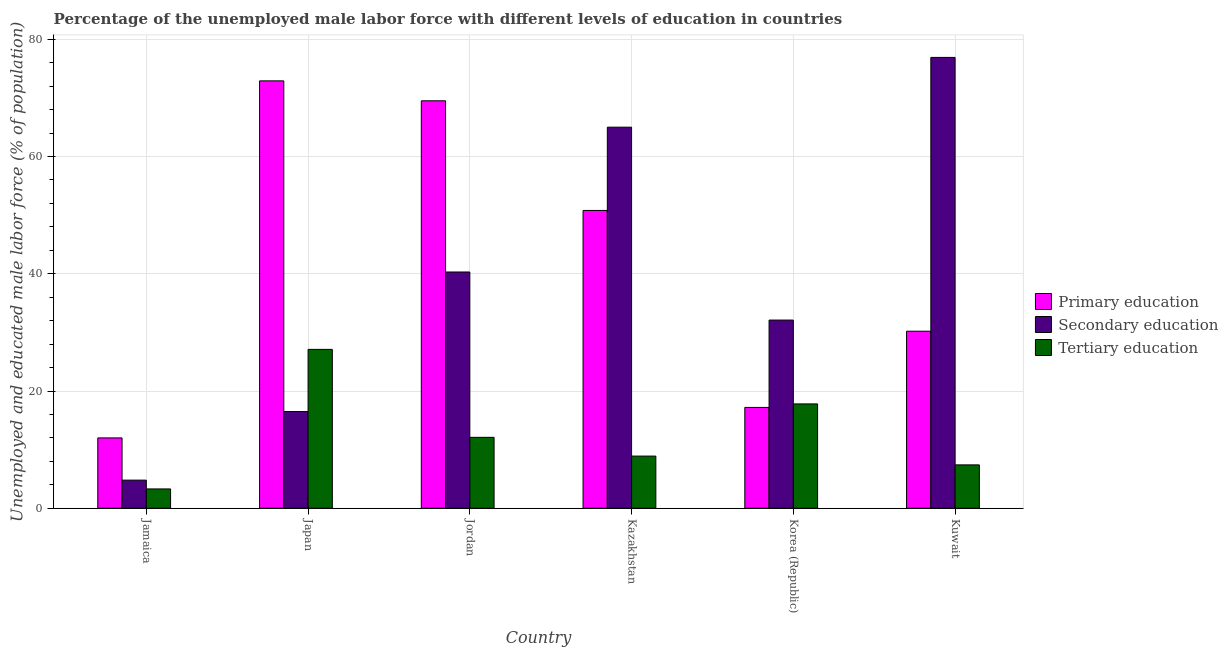How many groups of bars are there?
Provide a succinct answer. 6. Are the number of bars on each tick of the X-axis equal?
Offer a very short reply. Yes. What is the label of the 1st group of bars from the left?
Your response must be concise. Jamaica. In how many cases, is the number of bars for a given country not equal to the number of legend labels?
Your answer should be compact. 0. What is the percentage of male labor force who received primary education in Korea (Republic)?
Provide a succinct answer. 17.2. Across all countries, what is the maximum percentage of male labor force who received secondary education?
Provide a short and direct response. 76.9. Across all countries, what is the minimum percentage of male labor force who received tertiary education?
Your response must be concise. 3.3. In which country was the percentage of male labor force who received primary education minimum?
Your response must be concise. Jamaica. What is the total percentage of male labor force who received primary education in the graph?
Your response must be concise. 252.6. What is the difference between the percentage of male labor force who received primary education in Jordan and that in Kuwait?
Your answer should be very brief. 39.3. What is the difference between the percentage of male labor force who received tertiary education in Korea (Republic) and the percentage of male labor force who received secondary education in Jamaica?
Your response must be concise. 13. What is the average percentage of male labor force who received secondary education per country?
Your answer should be very brief. 39.27. What is the difference between the percentage of male labor force who received tertiary education and percentage of male labor force who received secondary education in Kuwait?
Provide a succinct answer. -69.5. What is the ratio of the percentage of male labor force who received tertiary education in Jamaica to that in Japan?
Keep it short and to the point. 0.12. What is the difference between the highest and the second highest percentage of male labor force who received primary education?
Give a very brief answer. 3.4. What is the difference between the highest and the lowest percentage of male labor force who received tertiary education?
Provide a succinct answer. 23.8. What does the 3rd bar from the left in Kazakhstan represents?
Offer a very short reply. Tertiary education. What does the 1st bar from the right in Kazakhstan represents?
Give a very brief answer. Tertiary education. How many bars are there?
Give a very brief answer. 18. Are all the bars in the graph horizontal?
Make the answer very short. No. How many countries are there in the graph?
Keep it short and to the point. 6. What is the difference between two consecutive major ticks on the Y-axis?
Offer a very short reply. 20. Does the graph contain any zero values?
Ensure brevity in your answer.  No. Does the graph contain grids?
Provide a short and direct response. Yes. Where does the legend appear in the graph?
Your answer should be very brief. Center right. How are the legend labels stacked?
Your response must be concise. Vertical. What is the title of the graph?
Your response must be concise. Percentage of the unemployed male labor force with different levels of education in countries. What is the label or title of the X-axis?
Offer a very short reply. Country. What is the label or title of the Y-axis?
Make the answer very short. Unemployed and educated male labor force (% of population). What is the Unemployed and educated male labor force (% of population) in Secondary education in Jamaica?
Give a very brief answer. 4.8. What is the Unemployed and educated male labor force (% of population) in Tertiary education in Jamaica?
Ensure brevity in your answer.  3.3. What is the Unemployed and educated male labor force (% of population) in Primary education in Japan?
Your response must be concise. 72.9. What is the Unemployed and educated male labor force (% of population) in Tertiary education in Japan?
Keep it short and to the point. 27.1. What is the Unemployed and educated male labor force (% of population) in Primary education in Jordan?
Keep it short and to the point. 69.5. What is the Unemployed and educated male labor force (% of population) of Secondary education in Jordan?
Provide a short and direct response. 40.3. What is the Unemployed and educated male labor force (% of population) in Tertiary education in Jordan?
Your response must be concise. 12.1. What is the Unemployed and educated male labor force (% of population) in Primary education in Kazakhstan?
Your answer should be compact. 50.8. What is the Unemployed and educated male labor force (% of population) in Tertiary education in Kazakhstan?
Offer a very short reply. 8.9. What is the Unemployed and educated male labor force (% of population) of Primary education in Korea (Republic)?
Keep it short and to the point. 17.2. What is the Unemployed and educated male labor force (% of population) of Secondary education in Korea (Republic)?
Provide a succinct answer. 32.1. What is the Unemployed and educated male labor force (% of population) in Tertiary education in Korea (Republic)?
Your answer should be very brief. 17.8. What is the Unemployed and educated male labor force (% of population) of Primary education in Kuwait?
Your response must be concise. 30.2. What is the Unemployed and educated male labor force (% of population) in Secondary education in Kuwait?
Offer a terse response. 76.9. What is the Unemployed and educated male labor force (% of population) of Tertiary education in Kuwait?
Keep it short and to the point. 7.4. Across all countries, what is the maximum Unemployed and educated male labor force (% of population) in Primary education?
Your answer should be very brief. 72.9. Across all countries, what is the maximum Unemployed and educated male labor force (% of population) in Secondary education?
Offer a terse response. 76.9. Across all countries, what is the maximum Unemployed and educated male labor force (% of population) of Tertiary education?
Your answer should be compact. 27.1. Across all countries, what is the minimum Unemployed and educated male labor force (% of population) of Primary education?
Keep it short and to the point. 12. Across all countries, what is the minimum Unemployed and educated male labor force (% of population) in Secondary education?
Offer a very short reply. 4.8. Across all countries, what is the minimum Unemployed and educated male labor force (% of population) of Tertiary education?
Give a very brief answer. 3.3. What is the total Unemployed and educated male labor force (% of population) in Primary education in the graph?
Ensure brevity in your answer.  252.6. What is the total Unemployed and educated male labor force (% of population) in Secondary education in the graph?
Ensure brevity in your answer.  235.6. What is the total Unemployed and educated male labor force (% of population) of Tertiary education in the graph?
Provide a short and direct response. 76.6. What is the difference between the Unemployed and educated male labor force (% of population) in Primary education in Jamaica and that in Japan?
Offer a very short reply. -60.9. What is the difference between the Unemployed and educated male labor force (% of population) of Tertiary education in Jamaica and that in Japan?
Your answer should be very brief. -23.8. What is the difference between the Unemployed and educated male labor force (% of population) of Primary education in Jamaica and that in Jordan?
Give a very brief answer. -57.5. What is the difference between the Unemployed and educated male labor force (% of population) of Secondary education in Jamaica and that in Jordan?
Provide a succinct answer. -35.5. What is the difference between the Unemployed and educated male labor force (% of population) of Tertiary education in Jamaica and that in Jordan?
Your response must be concise. -8.8. What is the difference between the Unemployed and educated male labor force (% of population) of Primary education in Jamaica and that in Kazakhstan?
Provide a short and direct response. -38.8. What is the difference between the Unemployed and educated male labor force (% of population) in Secondary education in Jamaica and that in Kazakhstan?
Your answer should be compact. -60.2. What is the difference between the Unemployed and educated male labor force (% of population) of Tertiary education in Jamaica and that in Kazakhstan?
Your response must be concise. -5.6. What is the difference between the Unemployed and educated male labor force (% of population) in Primary education in Jamaica and that in Korea (Republic)?
Keep it short and to the point. -5.2. What is the difference between the Unemployed and educated male labor force (% of population) in Secondary education in Jamaica and that in Korea (Republic)?
Your answer should be compact. -27.3. What is the difference between the Unemployed and educated male labor force (% of population) of Primary education in Jamaica and that in Kuwait?
Give a very brief answer. -18.2. What is the difference between the Unemployed and educated male labor force (% of population) in Secondary education in Jamaica and that in Kuwait?
Provide a short and direct response. -72.1. What is the difference between the Unemployed and educated male labor force (% of population) in Tertiary education in Jamaica and that in Kuwait?
Provide a short and direct response. -4.1. What is the difference between the Unemployed and educated male labor force (% of population) of Primary education in Japan and that in Jordan?
Provide a short and direct response. 3.4. What is the difference between the Unemployed and educated male labor force (% of population) of Secondary education in Japan and that in Jordan?
Provide a succinct answer. -23.8. What is the difference between the Unemployed and educated male labor force (% of population) in Tertiary education in Japan and that in Jordan?
Offer a terse response. 15. What is the difference between the Unemployed and educated male labor force (% of population) of Primary education in Japan and that in Kazakhstan?
Provide a succinct answer. 22.1. What is the difference between the Unemployed and educated male labor force (% of population) of Secondary education in Japan and that in Kazakhstan?
Your response must be concise. -48.5. What is the difference between the Unemployed and educated male labor force (% of population) in Tertiary education in Japan and that in Kazakhstan?
Offer a very short reply. 18.2. What is the difference between the Unemployed and educated male labor force (% of population) of Primary education in Japan and that in Korea (Republic)?
Make the answer very short. 55.7. What is the difference between the Unemployed and educated male labor force (% of population) in Secondary education in Japan and that in Korea (Republic)?
Offer a very short reply. -15.6. What is the difference between the Unemployed and educated male labor force (% of population) of Primary education in Japan and that in Kuwait?
Keep it short and to the point. 42.7. What is the difference between the Unemployed and educated male labor force (% of population) of Secondary education in Japan and that in Kuwait?
Your answer should be compact. -60.4. What is the difference between the Unemployed and educated male labor force (% of population) of Tertiary education in Japan and that in Kuwait?
Your response must be concise. 19.7. What is the difference between the Unemployed and educated male labor force (% of population) of Primary education in Jordan and that in Kazakhstan?
Provide a succinct answer. 18.7. What is the difference between the Unemployed and educated male labor force (% of population) of Secondary education in Jordan and that in Kazakhstan?
Keep it short and to the point. -24.7. What is the difference between the Unemployed and educated male labor force (% of population) in Primary education in Jordan and that in Korea (Republic)?
Offer a very short reply. 52.3. What is the difference between the Unemployed and educated male labor force (% of population) of Secondary education in Jordan and that in Korea (Republic)?
Your answer should be very brief. 8.2. What is the difference between the Unemployed and educated male labor force (% of population) of Primary education in Jordan and that in Kuwait?
Make the answer very short. 39.3. What is the difference between the Unemployed and educated male labor force (% of population) of Secondary education in Jordan and that in Kuwait?
Make the answer very short. -36.6. What is the difference between the Unemployed and educated male labor force (% of population) of Tertiary education in Jordan and that in Kuwait?
Offer a terse response. 4.7. What is the difference between the Unemployed and educated male labor force (% of population) of Primary education in Kazakhstan and that in Korea (Republic)?
Your response must be concise. 33.6. What is the difference between the Unemployed and educated male labor force (% of population) of Secondary education in Kazakhstan and that in Korea (Republic)?
Keep it short and to the point. 32.9. What is the difference between the Unemployed and educated male labor force (% of population) in Primary education in Kazakhstan and that in Kuwait?
Provide a short and direct response. 20.6. What is the difference between the Unemployed and educated male labor force (% of population) of Secondary education in Kazakhstan and that in Kuwait?
Give a very brief answer. -11.9. What is the difference between the Unemployed and educated male labor force (% of population) in Secondary education in Korea (Republic) and that in Kuwait?
Provide a succinct answer. -44.8. What is the difference between the Unemployed and educated male labor force (% of population) in Tertiary education in Korea (Republic) and that in Kuwait?
Offer a terse response. 10.4. What is the difference between the Unemployed and educated male labor force (% of population) in Primary education in Jamaica and the Unemployed and educated male labor force (% of population) in Secondary education in Japan?
Ensure brevity in your answer.  -4.5. What is the difference between the Unemployed and educated male labor force (% of population) of Primary education in Jamaica and the Unemployed and educated male labor force (% of population) of Tertiary education in Japan?
Offer a terse response. -15.1. What is the difference between the Unemployed and educated male labor force (% of population) of Secondary education in Jamaica and the Unemployed and educated male labor force (% of population) of Tertiary education in Japan?
Give a very brief answer. -22.3. What is the difference between the Unemployed and educated male labor force (% of population) of Primary education in Jamaica and the Unemployed and educated male labor force (% of population) of Secondary education in Jordan?
Your answer should be compact. -28.3. What is the difference between the Unemployed and educated male labor force (% of population) in Primary education in Jamaica and the Unemployed and educated male labor force (% of population) in Tertiary education in Jordan?
Provide a succinct answer. -0.1. What is the difference between the Unemployed and educated male labor force (% of population) of Secondary education in Jamaica and the Unemployed and educated male labor force (% of population) of Tertiary education in Jordan?
Keep it short and to the point. -7.3. What is the difference between the Unemployed and educated male labor force (% of population) of Primary education in Jamaica and the Unemployed and educated male labor force (% of population) of Secondary education in Kazakhstan?
Your answer should be very brief. -53. What is the difference between the Unemployed and educated male labor force (% of population) of Primary education in Jamaica and the Unemployed and educated male labor force (% of population) of Tertiary education in Kazakhstan?
Provide a succinct answer. 3.1. What is the difference between the Unemployed and educated male labor force (% of population) of Primary education in Jamaica and the Unemployed and educated male labor force (% of population) of Secondary education in Korea (Republic)?
Your answer should be very brief. -20.1. What is the difference between the Unemployed and educated male labor force (% of population) of Primary education in Jamaica and the Unemployed and educated male labor force (% of population) of Tertiary education in Korea (Republic)?
Your answer should be compact. -5.8. What is the difference between the Unemployed and educated male labor force (% of population) of Secondary education in Jamaica and the Unemployed and educated male labor force (% of population) of Tertiary education in Korea (Republic)?
Provide a succinct answer. -13. What is the difference between the Unemployed and educated male labor force (% of population) in Primary education in Jamaica and the Unemployed and educated male labor force (% of population) in Secondary education in Kuwait?
Offer a terse response. -64.9. What is the difference between the Unemployed and educated male labor force (% of population) of Primary education in Jamaica and the Unemployed and educated male labor force (% of population) of Tertiary education in Kuwait?
Make the answer very short. 4.6. What is the difference between the Unemployed and educated male labor force (% of population) of Primary education in Japan and the Unemployed and educated male labor force (% of population) of Secondary education in Jordan?
Your answer should be compact. 32.6. What is the difference between the Unemployed and educated male labor force (% of population) of Primary education in Japan and the Unemployed and educated male labor force (% of population) of Tertiary education in Jordan?
Your response must be concise. 60.8. What is the difference between the Unemployed and educated male labor force (% of population) of Secondary education in Japan and the Unemployed and educated male labor force (% of population) of Tertiary education in Kazakhstan?
Keep it short and to the point. 7.6. What is the difference between the Unemployed and educated male labor force (% of population) of Primary education in Japan and the Unemployed and educated male labor force (% of population) of Secondary education in Korea (Republic)?
Offer a very short reply. 40.8. What is the difference between the Unemployed and educated male labor force (% of population) in Primary education in Japan and the Unemployed and educated male labor force (% of population) in Tertiary education in Korea (Republic)?
Ensure brevity in your answer.  55.1. What is the difference between the Unemployed and educated male labor force (% of population) in Secondary education in Japan and the Unemployed and educated male labor force (% of population) in Tertiary education in Korea (Republic)?
Your answer should be very brief. -1.3. What is the difference between the Unemployed and educated male labor force (% of population) in Primary education in Japan and the Unemployed and educated male labor force (% of population) in Secondary education in Kuwait?
Provide a short and direct response. -4. What is the difference between the Unemployed and educated male labor force (% of population) in Primary education in Japan and the Unemployed and educated male labor force (% of population) in Tertiary education in Kuwait?
Keep it short and to the point. 65.5. What is the difference between the Unemployed and educated male labor force (% of population) in Secondary education in Japan and the Unemployed and educated male labor force (% of population) in Tertiary education in Kuwait?
Offer a terse response. 9.1. What is the difference between the Unemployed and educated male labor force (% of population) of Primary education in Jordan and the Unemployed and educated male labor force (% of population) of Tertiary education in Kazakhstan?
Offer a terse response. 60.6. What is the difference between the Unemployed and educated male labor force (% of population) in Secondary education in Jordan and the Unemployed and educated male labor force (% of population) in Tertiary education in Kazakhstan?
Your response must be concise. 31.4. What is the difference between the Unemployed and educated male labor force (% of population) of Primary education in Jordan and the Unemployed and educated male labor force (% of population) of Secondary education in Korea (Republic)?
Your response must be concise. 37.4. What is the difference between the Unemployed and educated male labor force (% of population) in Primary education in Jordan and the Unemployed and educated male labor force (% of population) in Tertiary education in Korea (Republic)?
Offer a very short reply. 51.7. What is the difference between the Unemployed and educated male labor force (% of population) in Primary education in Jordan and the Unemployed and educated male labor force (% of population) in Tertiary education in Kuwait?
Your answer should be compact. 62.1. What is the difference between the Unemployed and educated male labor force (% of population) in Secondary education in Jordan and the Unemployed and educated male labor force (% of population) in Tertiary education in Kuwait?
Ensure brevity in your answer.  32.9. What is the difference between the Unemployed and educated male labor force (% of population) of Primary education in Kazakhstan and the Unemployed and educated male labor force (% of population) of Tertiary education in Korea (Republic)?
Offer a terse response. 33. What is the difference between the Unemployed and educated male labor force (% of population) in Secondary education in Kazakhstan and the Unemployed and educated male labor force (% of population) in Tertiary education in Korea (Republic)?
Ensure brevity in your answer.  47.2. What is the difference between the Unemployed and educated male labor force (% of population) in Primary education in Kazakhstan and the Unemployed and educated male labor force (% of population) in Secondary education in Kuwait?
Ensure brevity in your answer.  -26.1. What is the difference between the Unemployed and educated male labor force (% of population) of Primary education in Kazakhstan and the Unemployed and educated male labor force (% of population) of Tertiary education in Kuwait?
Keep it short and to the point. 43.4. What is the difference between the Unemployed and educated male labor force (% of population) of Secondary education in Kazakhstan and the Unemployed and educated male labor force (% of population) of Tertiary education in Kuwait?
Give a very brief answer. 57.6. What is the difference between the Unemployed and educated male labor force (% of population) of Primary education in Korea (Republic) and the Unemployed and educated male labor force (% of population) of Secondary education in Kuwait?
Your answer should be very brief. -59.7. What is the difference between the Unemployed and educated male labor force (% of population) in Secondary education in Korea (Republic) and the Unemployed and educated male labor force (% of population) in Tertiary education in Kuwait?
Ensure brevity in your answer.  24.7. What is the average Unemployed and educated male labor force (% of population) in Primary education per country?
Keep it short and to the point. 42.1. What is the average Unemployed and educated male labor force (% of population) of Secondary education per country?
Ensure brevity in your answer.  39.27. What is the average Unemployed and educated male labor force (% of population) of Tertiary education per country?
Offer a very short reply. 12.77. What is the difference between the Unemployed and educated male labor force (% of population) in Primary education and Unemployed and educated male labor force (% of population) in Secondary education in Japan?
Your response must be concise. 56.4. What is the difference between the Unemployed and educated male labor force (% of population) of Primary education and Unemployed and educated male labor force (% of population) of Tertiary education in Japan?
Ensure brevity in your answer.  45.8. What is the difference between the Unemployed and educated male labor force (% of population) in Secondary education and Unemployed and educated male labor force (% of population) in Tertiary education in Japan?
Keep it short and to the point. -10.6. What is the difference between the Unemployed and educated male labor force (% of population) of Primary education and Unemployed and educated male labor force (% of population) of Secondary education in Jordan?
Offer a terse response. 29.2. What is the difference between the Unemployed and educated male labor force (% of population) of Primary education and Unemployed and educated male labor force (% of population) of Tertiary education in Jordan?
Offer a terse response. 57.4. What is the difference between the Unemployed and educated male labor force (% of population) of Secondary education and Unemployed and educated male labor force (% of population) of Tertiary education in Jordan?
Provide a succinct answer. 28.2. What is the difference between the Unemployed and educated male labor force (% of population) in Primary education and Unemployed and educated male labor force (% of population) in Secondary education in Kazakhstan?
Ensure brevity in your answer.  -14.2. What is the difference between the Unemployed and educated male labor force (% of population) in Primary education and Unemployed and educated male labor force (% of population) in Tertiary education in Kazakhstan?
Your answer should be very brief. 41.9. What is the difference between the Unemployed and educated male labor force (% of population) of Secondary education and Unemployed and educated male labor force (% of population) of Tertiary education in Kazakhstan?
Keep it short and to the point. 56.1. What is the difference between the Unemployed and educated male labor force (% of population) in Primary education and Unemployed and educated male labor force (% of population) in Secondary education in Korea (Republic)?
Keep it short and to the point. -14.9. What is the difference between the Unemployed and educated male labor force (% of population) in Primary education and Unemployed and educated male labor force (% of population) in Tertiary education in Korea (Republic)?
Your response must be concise. -0.6. What is the difference between the Unemployed and educated male labor force (% of population) in Secondary education and Unemployed and educated male labor force (% of population) in Tertiary education in Korea (Republic)?
Provide a short and direct response. 14.3. What is the difference between the Unemployed and educated male labor force (% of population) in Primary education and Unemployed and educated male labor force (% of population) in Secondary education in Kuwait?
Give a very brief answer. -46.7. What is the difference between the Unemployed and educated male labor force (% of population) in Primary education and Unemployed and educated male labor force (% of population) in Tertiary education in Kuwait?
Offer a terse response. 22.8. What is the difference between the Unemployed and educated male labor force (% of population) in Secondary education and Unemployed and educated male labor force (% of population) in Tertiary education in Kuwait?
Make the answer very short. 69.5. What is the ratio of the Unemployed and educated male labor force (% of population) in Primary education in Jamaica to that in Japan?
Keep it short and to the point. 0.16. What is the ratio of the Unemployed and educated male labor force (% of population) of Secondary education in Jamaica to that in Japan?
Keep it short and to the point. 0.29. What is the ratio of the Unemployed and educated male labor force (% of population) in Tertiary education in Jamaica to that in Japan?
Your answer should be very brief. 0.12. What is the ratio of the Unemployed and educated male labor force (% of population) in Primary education in Jamaica to that in Jordan?
Your answer should be very brief. 0.17. What is the ratio of the Unemployed and educated male labor force (% of population) in Secondary education in Jamaica to that in Jordan?
Ensure brevity in your answer.  0.12. What is the ratio of the Unemployed and educated male labor force (% of population) of Tertiary education in Jamaica to that in Jordan?
Make the answer very short. 0.27. What is the ratio of the Unemployed and educated male labor force (% of population) in Primary education in Jamaica to that in Kazakhstan?
Ensure brevity in your answer.  0.24. What is the ratio of the Unemployed and educated male labor force (% of population) of Secondary education in Jamaica to that in Kazakhstan?
Your answer should be very brief. 0.07. What is the ratio of the Unemployed and educated male labor force (% of population) in Tertiary education in Jamaica to that in Kazakhstan?
Make the answer very short. 0.37. What is the ratio of the Unemployed and educated male labor force (% of population) of Primary education in Jamaica to that in Korea (Republic)?
Your answer should be very brief. 0.7. What is the ratio of the Unemployed and educated male labor force (% of population) of Secondary education in Jamaica to that in Korea (Republic)?
Your answer should be compact. 0.15. What is the ratio of the Unemployed and educated male labor force (% of population) in Tertiary education in Jamaica to that in Korea (Republic)?
Provide a succinct answer. 0.19. What is the ratio of the Unemployed and educated male labor force (% of population) of Primary education in Jamaica to that in Kuwait?
Make the answer very short. 0.4. What is the ratio of the Unemployed and educated male labor force (% of population) of Secondary education in Jamaica to that in Kuwait?
Keep it short and to the point. 0.06. What is the ratio of the Unemployed and educated male labor force (% of population) of Tertiary education in Jamaica to that in Kuwait?
Your answer should be compact. 0.45. What is the ratio of the Unemployed and educated male labor force (% of population) in Primary education in Japan to that in Jordan?
Provide a short and direct response. 1.05. What is the ratio of the Unemployed and educated male labor force (% of population) of Secondary education in Japan to that in Jordan?
Your answer should be compact. 0.41. What is the ratio of the Unemployed and educated male labor force (% of population) in Tertiary education in Japan to that in Jordan?
Provide a short and direct response. 2.24. What is the ratio of the Unemployed and educated male labor force (% of population) of Primary education in Japan to that in Kazakhstan?
Your answer should be compact. 1.44. What is the ratio of the Unemployed and educated male labor force (% of population) of Secondary education in Japan to that in Kazakhstan?
Your response must be concise. 0.25. What is the ratio of the Unemployed and educated male labor force (% of population) in Tertiary education in Japan to that in Kazakhstan?
Offer a very short reply. 3.04. What is the ratio of the Unemployed and educated male labor force (% of population) in Primary education in Japan to that in Korea (Republic)?
Make the answer very short. 4.24. What is the ratio of the Unemployed and educated male labor force (% of population) in Secondary education in Japan to that in Korea (Republic)?
Provide a succinct answer. 0.51. What is the ratio of the Unemployed and educated male labor force (% of population) in Tertiary education in Japan to that in Korea (Republic)?
Provide a short and direct response. 1.52. What is the ratio of the Unemployed and educated male labor force (% of population) in Primary education in Japan to that in Kuwait?
Ensure brevity in your answer.  2.41. What is the ratio of the Unemployed and educated male labor force (% of population) of Secondary education in Japan to that in Kuwait?
Keep it short and to the point. 0.21. What is the ratio of the Unemployed and educated male labor force (% of population) of Tertiary education in Japan to that in Kuwait?
Provide a succinct answer. 3.66. What is the ratio of the Unemployed and educated male labor force (% of population) in Primary education in Jordan to that in Kazakhstan?
Provide a succinct answer. 1.37. What is the ratio of the Unemployed and educated male labor force (% of population) in Secondary education in Jordan to that in Kazakhstan?
Make the answer very short. 0.62. What is the ratio of the Unemployed and educated male labor force (% of population) in Tertiary education in Jordan to that in Kazakhstan?
Offer a terse response. 1.36. What is the ratio of the Unemployed and educated male labor force (% of population) in Primary education in Jordan to that in Korea (Republic)?
Your answer should be very brief. 4.04. What is the ratio of the Unemployed and educated male labor force (% of population) of Secondary education in Jordan to that in Korea (Republic)?
Offer a terse response. 1.26. What is the ratio of the Unemployed and educated male labor force (% of population) in Tertiary education in Jordan to that in Korea (Republic)?
Provide a succinct answer. 0.68. What is the ratio of the Unemployed and educated male labor force (% of population) in Primary education in Jordan to that in Kuwait?
Give a very brief answer. 2.3. What is the ratio of the Unemployed and educated male labor force (% of population) in Secondary education in Jordan to that in Kuwait?
Your response must be concise. 0.52. What is the ratio of the Unemployed and educated male labor force (% of population) in Tertiary education in Jordan to that in Kuwait?
Your answer should be compact. 1.64. What is the ratio of the Unemployed and educated male labor force (% of population) in Primary education in Kazakhstan to that in Korea (Republic)?
Your answer should be compact. 2.95. What is the ratio of the Unemployed and educated male labor force (% of population) of Secondary education in Kazakhstan to that in Korea (Republic)?
Your response must be concise. 2.02. What is the ratio of the Unemployed and educated male labor force (% of population) in Primary education in Kazakhstan to that in Kuwait?
Provide a succinct answer. 1.68. What is the ratio of the Unemployed and educated male labor force (% of population) in Secondary education in Kazakhstan to that in Kuwait?
Provide a short and direct response. 0.85. What is the ratio of the Unemployed and educated male labor force (% of population) in Tertiary education in Kazakhstan to that in Kuwait?
Make the answer very short. 1.2. What is the ratio of the Unemployed and educated male labor force (% of population) of Primary education in Korea (Republic) to that in Kuwait?
Make the answer very short. 0.57. What is the ratio of the Unemployed and educated male labor force (% of population) in Secondary education in Korea (Republic) to that in Kuwait?
Offer a very short reply. 0.42. What is the ratio of the Unemployed and educated male labor force (% of population) of Tertiary education in Korea (Republic) to that in Kuwait?
Offer a terse response. 2.41. What is the difference between the highest and the second highest Unemployed and educated male labor force (% of population) in Primary education?
Make the answer very short. 3.4. What is the difference between the highest and the lowest Unemployed and educated male labor force (% of population) of Primary education?
Your answer should be very brief. 60.9. What is the difference between the highest and the lowest Unemployed and educated male labor force (% of population) of Secondary education?
Give a very brief answer. 72.1. What is the difference between the highest and the lowest Unemployed and educated male labor force (% of population) of Tertiary education?
Make the answer very short. 23.8. 